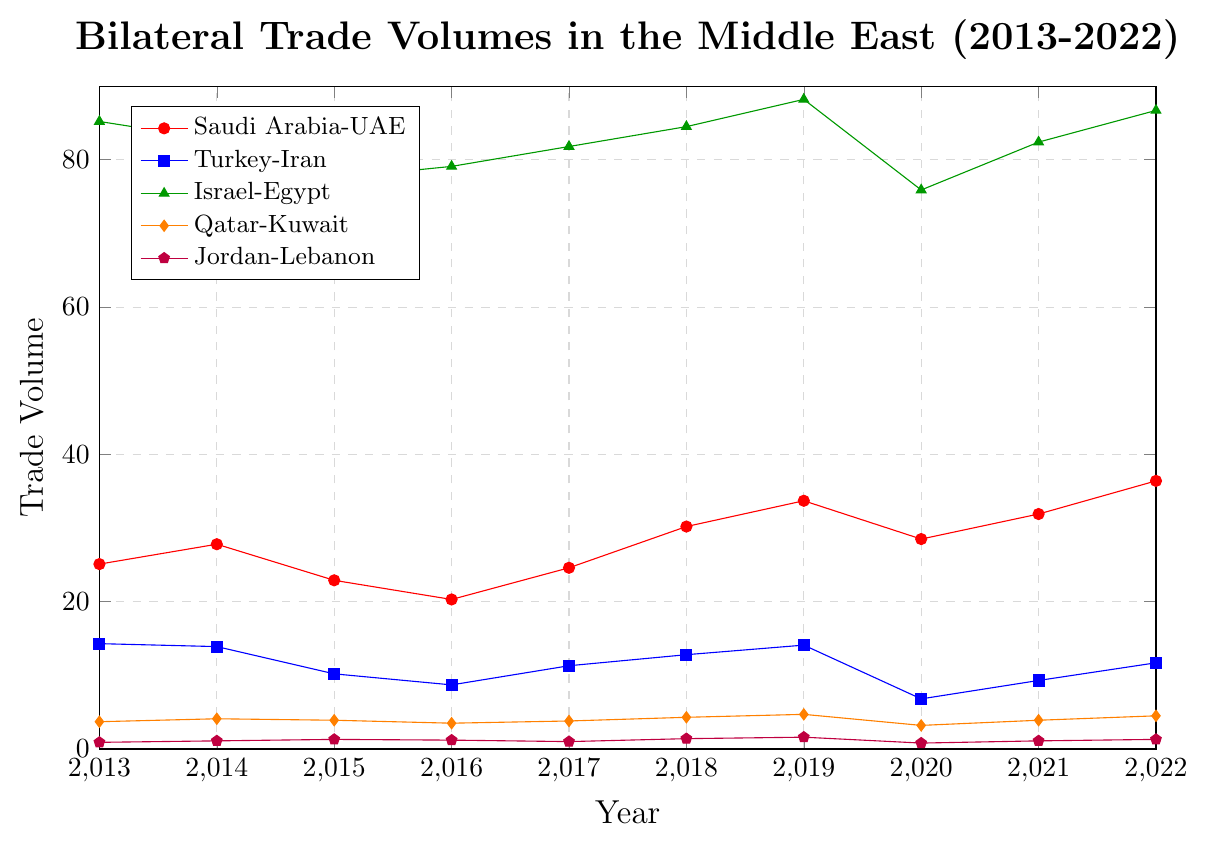Which trade pair shows the highest overall trade volume in 2022? From the chart, look at where the trade volumes for each trade pair stand in 2022. The Israel-Egypt trade volume reaches the highest point compared to others at 86.7 units.
Answer: Israel-Egypt What is the lowest trade volume recorded for Jordan-Lebanon over the decade? The chart shows the trade volumes from 2013 to 2022. Jordan-Lebanon has its lowest point at 0.8 in 2020.
Answer: 0.8 How did the Turkey-Iran trade volume change between 2019 and 2020? Observe the values for Turkey-Iran in 2019 (14.1) and 2020 (6.8). Subtract the 2020 value from the 2019 value: 14.1 - 6.8 = 7.3. The trade volume decreased by 7.3 units.
Answer: Decreased by 7.3 Which trade pair showed the most consistent growth from 2013 to 2022? Compare the general trends of each trade pair line from 2013 to 2022. The Saudi Arabia-UAE trade pair shows a mostly upward trend, indicating consistent growth over the decade.
Answer: Saudi Arabia-UAE Between which years did Qatar-Kuwait see the greatest increase in trade volume? Examine the increments in trade volume for Qatar-Kuwait between every two consecutive years. The greatest increase occurred between 2018 (4.3) and 2019 (4.7), which is an increase of 0.4 units.
Answer: 2018-2019 What was the average trade volume for Israel-Egypt over the decade? Sum the annual trade volumes for Israel-Egypt from 2013 to 2022, then divide by the number of years (10). Calculation: (85.2 + 82.7 + 77.5 + 79.1 + 81.8 + 84.5 + 88.2 + 75.9 + 82.4 + 86.7) / 10 = 82.4.
Answer: 82.4 Which year did the Saudi Arabia-UAE trade volume experience the largest drop compared to the previous year? Calculate the differences in trade volume for Saudi Arabia-UAE between every two consecutive years. The largest drop is between 2014 (27.8) and 2015 (22.9), with a decrease of 4.9 units.
Answer: 2015 Did any trade pairs achieve their peak value in 2022? Look at the values for 2022 for each trade pair and compare them to previous years. Saudi Arabia-UAE and Israel-Egypt both achieved their peak values in 2022.
Answer: Saudi Arabia-UAE, Israel-Egypt What's the total trade volume for 2020 across all trade pairs? Sum the trade volumes for all trade pairs in 2020: 28.5 (Saudi Arabia-UAE) + 6.8 (Turkey-Iran) + 75.9 (Israel-Egypt) + 3.2 (Qatar-Kuwait) + 0.8 (Jordan-Lebanon) = 115.2 units.
Answer: 115.2 